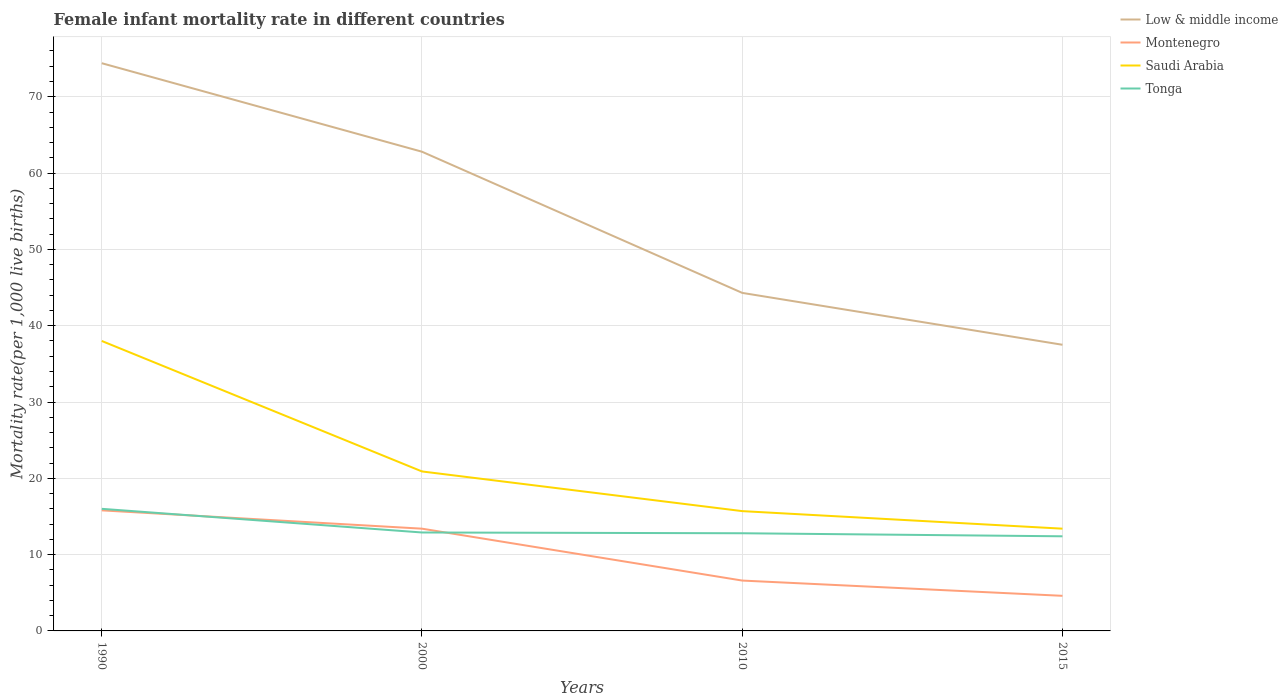Does the line corresponding to Low & middle income intersect with the line corresponding to Montenegro?
Your answer should be very brief. No. Is the number of lines equal to the number of legend labels?
Ensure brevity in your answer.  Yes. Across all years, what is the maximum female infant mortality rate in Saudi Arabia?
Provide a short and direct response. 13.4. In which year was the female infant mortality rate in Montenegro maximum?
Provide a short and direct response. 2015. What is the total female infant mortality rate in Tonga in the graph?
Your response must be concise. 3.2. What is the difference between the highest and the second highest female infant mortality rate in Montenegro?
Give a very brief answer. 11.2. How many lines are there?
Your answer should be compact. 4. How many years are there in the graph?
Keep it short and to the point. 4. What is the difference between two consecutive major ticks on the Y-axis?
Offer a terse response. 10. Are the values on the major ticks of Y-axis written in scientific E-notation?
Offer a terse response. No. Does the graph contain grids?
Ensure brevity in your answer.  Yes. How are the legend labels stacked?
Make the answer very short. Vertical. What is the title of the graph?
Provide a succinct answer. Female infant mortality rate in different countries. Does "Timor-Leste" appear as one of the legend labels in the graph?
Give a very brief answer. No. What is the label or title of the Y-axis?
Your answer should be compact. Mortality rate(per 1,0 live births). What is the Mortality rate(per 1,000 live births) of Low & middle income in 1990?
Your response must be concise. 74.4. What is the Mortality rate(per 1,000 live births) of Montenegro in 1990?
Keep it short and to the point. 15.8. What is the Mortality rate(per 1,000 live births) in Saudi Arabia in 1990?
Offer a very short reply. 38. What is the Mortality rate(per 1,000 live births) of Tonga in 1990?
Keep it short and to the point. 16. What is the Mortality rate(per 1,000 live births) of Low & middle income in 2000?
Ensure brevity in your answer.  62.8. What is the Mortality rate(per 1,000 live births) of Montenegro in 2000?
Your answer should be very brief. 13.4. What is the Mortality rate(per 1,000 live births) of Saudi Arabia in 2000?
Make the answer very short. 20.9. What is the Mortality rate(per 1,000 live births) in Tonga in 2000?
Offer a very short reply. 12.9. What is the Mortality rate(per 1,000 live births) of Low & middle income in 2010?
Your answer should be compact. 44.3. What is the Mortality rate(per 1,000 live births) of Montenegro in 2010?
Your response must be concise. 6.6. What is the Mortality rate(per 1,000 live births) of Tonga in 2010?
Keep it short and to the point. 12.8. What is the Mortality rate(per 1,000 live births) in Low & middle income in 2015?
Ensure brevity in your answer.  37.5. What is the Mortality rate(per 1,000 live births) of Saudi Arabia in 2015?
Provide a succinct answer. 13.4. What is the Mortality rate(per 1,000 live births) of Tonga in 2015?
Offer a very short reply. 12.4. Across all years, what is the maximum Mortality rate(per 1,000 live births) in Low & middle income?
Keep it short and to the point. 74.4. Across all years, what is the minimum Mortality rate(per 1,000 live births) in Low & middle income?
Provide a succinct answer. 37.5. Across all years, what is the minimum Mortality rate(per 1,000 live births) of Saudi Arabia?
Give a very brief answer. 13.4. What is the total Mortality rate(per 1,000 live births) in Low & middle income in the graph?
Your answer should be very brief. 219. What is the total Mortality rate(per 1,000 live births) in Montenegro in the graph?
Provide a short and direct response. 40.4. What is the total Mortality rate(per 1,000 live births) in Tonga in the graph?
Provide a short and direct response. 54.1. What is the difference between the Mortality rate(per 1,000 live births) of Montenegro in 1990 and that in 2000?
Make the answer very short. 2.4. What is the difference between the Mortality rate(per 1,000 live births) in Low & middle income in 1990 and that in 2010?
Your answer should be compact. 30.1. What is the difference between the Mortality rate(per 1,000 live births) in Saudi Arabia in 1990 and that in 2010?
Provide a short and direct response. 22.3. What is the difference between the Mortality rate(per 1,000 live births) of Low & middle income in 1990 and that in 2015?
Your response must be concise. 36.9. What is the difference between the Mortality rate(per 1,000 live births) of Montenegro in 1990 and that in 2015?
Ensure brevity in your answer.  11.2. What is the difference between the Mortality rate(per 1,000 live births) in Saudi Arabia in 1990 and that in 2015?
Offer a very short reply. 24.6. What is the difference between the Mortality rate(per 1,000 live births) in Tonga in 1990 and that in 2015?
Ensure brevity in your answer.  3.6. What is the difference between the Mortality rate(per 1,000 live births) in Montenegro in 2000 and that in 2010?
Your response must be concise. 6.8. What is the difference between the Mortality rate(per 1,000 live births) of Saudi Arabia in 2000 and that in 2010?
Offer a terse response. 5.2. What is the difference between the Mortality rate(per 1,000 live births) in Low & middle income in 2000 and that in 2015?
Keep it short and to the point. 25.3. What is the difference between the Mortality rate(per 1,000 live births) of Low & middle income in 2010 and that in 2015?
Give a very brief answer. 6.8. What is the difference between the Mortality rate(per 1,000 live births) in Montenegro in 2010 and that in 2015?
Your answer should be compact. 2. What is the difference between the Mortality rate(per 1,000 live births) in Saudi Arabia in 2010 and that in 2015?
Keep it short and to the point. 2.3. What is the difference between the Mortality rate(per 1,000 live births) in Low & middle income in 1990 and the Mortality rate(per 1,000 live births) in Montenegro in 2000?
Provide a short and direct response. 61. What is the difference between the Mortality rate(per 1,000 live births) of Low & middle income in 1990 and the Mortality rate(per 1,000 live births) of Saudi Arabia in 2000?
Offer a terse response. 53.5. What is the difference between the Mortality rate(per 1,000 live births) of Low & middle income in 1990 and the Mortality rate(per 1,000 live births) of Tonga in 2000?
Offer a very short reply. 61.5. What is the difference between the Mortality rate(per 1,000 live births) in Montenegro in 1990 and the Mortality rate(per 1,000 live births) in Tonga in 2000?
Keep it short and to the point. 2.9. What is the difference between the Mortality rate(per 1,000 live births) in Saudi Arabia in 1990 and the Mortality rate(per 1,000 live births) in Tonga in 2000?
Keep it short and to the point. 25.1. What is the difference between the Mortality rate(per 1,000 live births) of Low & middle income in 1990 and the Mortality rate(per 1,000 live births) of Montenegro in 2010?
Give a very brief answer. 67.8. What is the difference between the Mortality rate(per 1,000 live births) in Low & middle income in 1990 and the Mortality rate(per 1,000 live births) in Saudi Arabia in 2010?
Provide a succinct answer. 58.7. What is the difference between the Mortality rate(per 1,000 live births) of Low & middle income in 1990 and the Mortality rate(per 1,000 live births) of Tonga in 2010?
Your answer should be very brief. 61.6. What is the difference between the Mortality rate(per 1,000 live births) of Montenegro in 1990 and the Mortality rate(per 1,000 live births) of Tonga in 2010?
Keep it short and to the point. 3. What is the difference between the Mortality rate(per 1,000 live births) of Saudi Arabia in 1990 and the Mortality rate(per 1,000 live births) of Tonga in 2010?
Give a very brief answer. 25.2. What is the difference between the Mortality rate(per 1,000 live births) in Low & middle income in 1990 and the Mortality rate(per 1,000 live births) in Montenegro in 2015?
Offer a terse response. 69.8. What is the difference between the Mortality rate(per 1,000 live births) in Low & middle income in 1990 and the Mortality rate(per 1,000 live births) in Saudi Arabia in 2015?
Ensure brevity in your answer.  61. What is the difference between the Mortality rate(per 1,000 live births) in Montenegro in 1990 and the Mortality rate(per 1,000 live births) in Saudi Arabia in 2015?
Offer a very short reply. 2.4. What is the difference between the Mortality rate(per 1,000 live births) in Saudi Arabia in 1990 and the Mortality rate(per 1,000 live births) in Tonga in 2015?
Give a very brief answer. 25.6. What is the difference between the Mortality rate(per 1,000 live births) in Low & middle income in 2000 and the Mortality rate(per 1,000 live births) in Montenegro in 2010?
Ensure brevity in your answer.  56.2. What is the difference between the Mortality rate(per 1,000 live births) in Low & middle income in 2000 and the Mortality rate(per 1,000 live births) in Saudi Arabia in 2010?
Offer a terse response. 47.1. What is the difference between the Mortality rate(per 1,000 live births) of Montenegro in 2000 and the Mortality rate(per 1,000 live births) of Tonga in 2010?
Your answer should be very brief. 0.6. What is the difference between the Mortality rate(per 1,000 live births) in Low & middle income in 2000 and the Mortality rate(per 1,000 live births) in Montenegro in 2015?
Provide a succinct answer. 58.2. What is the difference between the Mortality rate(per 1,000 live births) in Low & middle income in 2000 and the Mortality rate(per 1,000 live births) in Saudi Arabia in 2015?
Your answer should be compact. 49.4. What is the difference between the Mortality rate(per 1,000 live births) in Low & middle income in 2000 and the Mortality rate(per 1,000 live births) in Tonga in 2015?
Offer a very short reply. 50.4. What is the difference between the Mortality rate(per 1,000 live births) in Saudi Arabia in 2000 and the Mortality rate(per 1,000 live births) in Tonga in 2015?
Offer a terse response. 8.5. What is the difference between the Mortality rate(per 1,000 live births) of Low & middle income in 2010 and the Mortality rate(per 1,000 live births) of Montenegro in 2015?
Give a very brief answer. 39.7. What is the difference between the Mortality rate(per 1,000 live births) in Low & middle income in 2010 and the Mortality rate(per 1,000 live births) in Saudi Arabia in 2015?
Ensure brevity in your answer.  30.9. What is the difference between the Mortality rate(per 1,000 live births) in Low & middle income in 2010 and the Mortality rate(per 1,000 live births) in Tonga in 2015?
Offer a terse response. 31.9. What is the difference between the Mortality rate(per 1,000 live births) of Montenegro in 2010 and the Mortality rate(per 1,000 live births) of Saudi Arabia in 2015?
Your answer should be very brief. -6.8. What is the difference between the Mortality rate(per 1,000 live births) in Montenegro in 2010 and the Mortality rate(per 1,000 live births) in Tonga in 2015?
Your answer should be very brief. -5.8. What is the difference between the Mortality rate(per 1,000 live births) of Saudi Arabia in 2010 and the Mortality rate(per 1,000 live births) of Tonga in 2015?
Your response must be concise. 3.3. What is the average Mortality rate(per 1,000 live births) in Low & middle income per year?
Your answer should be compact. 54.75. What is the average Mortality rate(per 1,000 live births) of Montenegro per year?
Your response must be concise. 10.1. What is the average Mortality rate(per 1,000 live births) in Tonga per year?
Make the answer very short. 13.53. In the year 1990, what is the difference between the Mortality rate(per 1,000 live births) in Low & middle income and Mortality rate(per 1,000 live births) in Montenegro?
Offer a very short reply. 58.6. In the year 1990, what is the difference between the Mortality rate(per 1,000 live births) in Low & middle income and Mortality rate(per 1,000 live births) in Saudi Arabia?
Provide a short and direct response. 36.4. In the year 1990, what is the difference between the Mortality rate(per 1,000 live births) in Low & middle income and Mortality rate(per 1,000 live births) in Tonga?
Your answer should be compact. 58.4. In the year 1990, what is the difference between the Mortality rate(per 1,000 live births) of Montenegro and Mortality rate(per 1,000 live births) of Saudi Arabia?
Keep it short and to the point. -22.2. In the year 1990, what is the difference between the Mortality rate(per 1,000 live births) in Montenegro and Mortality rate(per 1,000 live births) in Tonga?
Your response must be concise. -0.2. In the year 2000, what is the difference between the Mortality rate(per 1,000 live births) of Low & middle income and Mortality rate(per 1,000 live births) of Montenegro?
Your answer should be very brief. 49.4. In the year 2000, what is the difference between the Mortality rate(per 1,000 live births) of Low & middle income and Mortality rate(per 1,000 live births) of Saudi Arabia?
Make the answer very short. 41.9. In the year 2000, what is the difference between the Mortality rate(per 1,000 live births) of Low & middle income and Mortality rate(per 1,000 live births) of Tonga?
Your answer should be compact. 49.9. In the year 2000, what is the difference between the Mortality rate(per 1,000 live births) of Saudi Arabia and Mortality rate(per 1,000 live births) of Tonga?
Provide a succinct answer. 8. In the year 2010, what is the difference between the Mortality rate(per 1,000 live births) of Low & middle income and Mortality rate(per 1,000 live births) of Montenegro?
Offer a very short reply. 37.7. In the year 2010, what is the difference between the Mortality rate(per 1,000 live births) of Low & middle income and Mortality rate(per 1,000 live births) of Saudi Arabia?
Ensure brevity in your answer.  28.6. In the year 2010, what is the difference between the Mortality rate(per 1,000 live births) in Low & middle income and Mortality rate(per 1,000 live births) in Tonga?
Provide a short and direct response. 31.5. In the year 2010, what is the difference between the Mortality rate(per 1,000 live births) of Montenegro and Mortality rate(per 1,000 live births) of Saudi Arabia?
Offer a very short reply. -9.1. In the year 2010, what is the difference between the Mortality rate(per 1,000 live births) of Montenegro and Mortality rate(per 1,000 live births) of Tonga?
Your answer should be compact. -6.2. In the year 2010, what is the difference between the Mortality rate(per 1,000 live births) in Saudi Arabia and Mortality rate(per 1,000 live births) in Tonga?
Give a very brief answer. 2.9. In the year 2015, what is the difference between the Mortality rate(per 1,000 live births) of Low & middle income and Mortality rate(per 1,000 live births) of Montenegro?
Provide a succinct answer. 32.9. In the year 2015, what is the difference between the Mortality rate(per 1,000 live births) of Low & middle income and Mortality rate(per 1,000 live births) of Saudi Arabia?
Keep it short and to the point. 24.1. In the year 2015, what is the difference between the Mortality rate(per 1,000 live births) of Low & middle income and Mortality rate(per 1,000 live births) of Tonga?
Your answer should be very brief. 25.1. In the year 2015, what is the difference between the Mortality rate(per 1,000 live births) of Montenegro and Mortality rate(per 1,000 live births) of Tonga?
Offer a very short reply. -7.8. In the year 2015, what is the difference between the Mortality rate(per 1,000 live births) of Saudi Arabia and Mortality rate(per 1,000 live births) of Tonga?
Offer a very short reply. 1. What is the ratio of the Mortality rate(per 1,000 live births) in Low & middle income in 1990 to that in 2000?
Your response must be concise. 1.18. What is the ratio of the Mortality rate(per 1,000 live births) in Montenegro in 1990 to that in 2000?
Your response must be concise. 1.18. What is the ratio of the Mortality rate(per 1,000 live births) in Saudi Arabia in 1990 to that in 2000?
Your answer should be very brief. 1.82. What is the ratio of the Mortality rate(per 1,000 live births) in Tonga in 1990 to that in 2000?
Your answer should be very brief. 1.24. What is the ratio of the Mortality rate(per 1,000 live births) of Low & middle income in 1990 to that in 2010?
Make the answer very short. 1.68. What is the ratio of the Mortality rate(per 1,000 live births) of Montenegro in 1990 to that in 2010?
Your response must be concise. 2.39. What is the ratio of the Mortality rate(per 1,000 live births) of Saudi Arabia in 1990 to that in 2010?
Provide a succinct answer. 2.42. What is the ratio of the Mortality rate(per 1,000 live births) in Tonga in 1990 to that in 2010?
Provide a short and direct response. 1.25. What is the ratio of the Mortality rate(per 1,000 live births) in Low & middle income in 1990 to that in 2015?
Provide a short and direct response. 1.98. What is the ratio of the Mortality rate(per 1,000 live births) of Montenegro in 1990 to that in 2015?
Provide a short and direct response. 3.43. What is the ratio of the Mortality rate(per 1,000 live births) in Saudi Arabia in 1990 to that in 2015?
Give a very brief answer. 2.84. What is the ratio of the Mortality rate(per 1,000 live births) of Tonga in 1990 to that in 2015?
Provide a short and direct response. 1.29. What is the ratio of the Mortality rate(per 1,000 live births) of Low & middle income in 2000 to that in 2010?
Give a very brief answer. 1.42. What is the ratio of the Mortality rate(per 1,000 live births) in Montenegro in 2000 to that in 2010?
Make the answer very short. 2.03. What is the ratio of the Mortality rate(per 1,000 live births) of Saudi Arabia in 2000 to that in 2010?
Your response must be concise. 1.33. What is the ratio of the Mortality rate(per 1,000 live births) of Low & middle income in 2000 to that in 2015?
Give a very brief answer. 1.67. What is the ratio of the Mortality rate(per 1,000 live births) in Montenegro in 2000 to that in 2015?
Provide a succinct answer. 2.91. What is the ratio of the Mortality rate(per 1,000 live births) of Saudi Arabia in 2000 to that in 2015?
Ensure brevity in your answer.  1.56. What is the ratio of the Mortality rate(per 1,000 live births) of Tonga in 2000 to that in 2015?
Keep it short and to the point. 1.04. What is the ratio of the Mortality rate(per 1,000 live births) of Low & middle income in 2010 to that in 2015?
Keep it short and to the point. 1.18. What is the ratio of the Mortality rate(per 1,000 live births) in Montenegro in 2010 to that in 2015?
Your response must be concise. 1.43. What is the ratio of the Mortality rate(per 1,000 live births) in Saudi Arabia in 2010 to that in 2015?
Ensure brevity in your answer.  1.17. What is the ratio of the Mortality rate(per 1,000 live births) in Tonga in 2010 to that in 2015?
Your answer should be compact. 1.03. What is the difference between the highest and the second highest Mortality rate(per 1,000 live births) in Low & middle income?
Offer a terse response. 11.6. What is the difference between the highest and the second highest Mortality rate(per 1,000 live births) in Tonga?
Offer a terse response. 3.1. What is the difference between the highest and the lowest Mortality rate(per 1,000 live births) of Low & middle income?
Keep it short and to the point. 36.9. What is the difference between the highest and the lowest Mortality rate(per 1,000 live births) of Montenegro?
Provide a short and direct response. 11.2. What is the difference between the highest and the lowest Mortality rate(per 1,000 live births) in Saudi Arabia?
Provide a succinct answer. 24.6. 